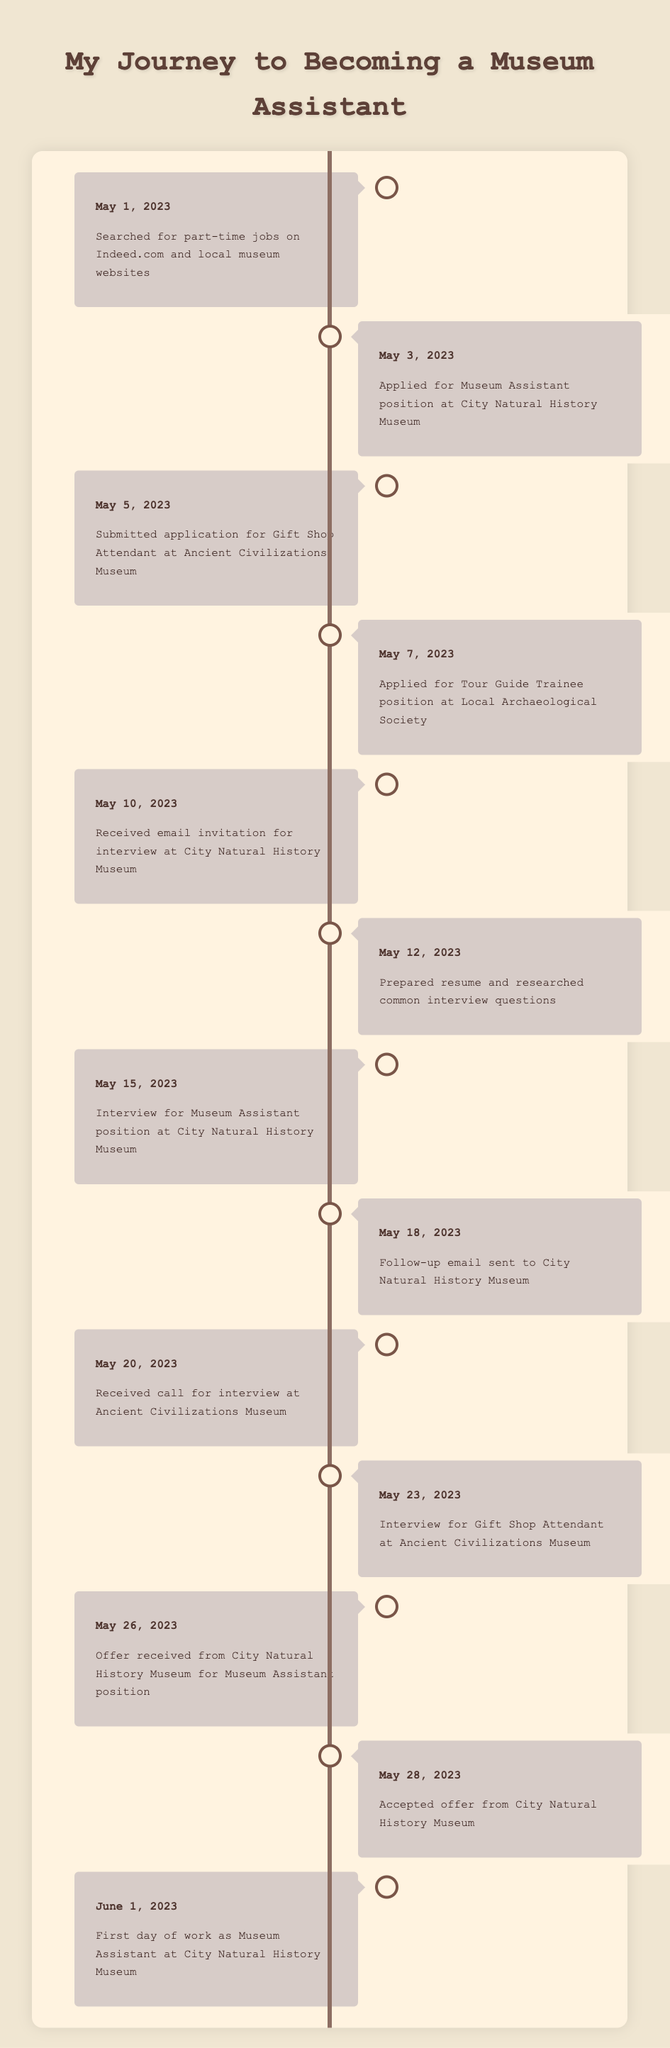What date did you apply for the Museum Assistant position? The application for the Museum Assistant position at the City Natural History Museum was submitted on May 3, 2023, as indicated in the timeline.
Answer: May 3, 2023 How many interviews did you have in total? There were two interviews listed in the timeline: the first for the Museum Assistant position on May 15, 2023, and the second for the Gift Shop Attendant on May 23, 2023. This totals to 2 interviews.
Answer: 2 What was the first event listed in the timeline? The first event in the timeline is "Searched for part-time jobs on Indeed.com and local museum websites," which occurred on May 1, 2023.
Answer: Searched for part-time jobs on Indeed.com and local museum websites Did you receive a job offer from the Ancient Civilizations Museum? There is no mention of receiving an offer from the Ancient Civilizations Museum in the timeline. Therefore, the answer is no.
Answer: No Which museum offered you a position, and when was it? The City Natural History Museum offered the Museum Assistant position on May 26, 2023. This can be determined from the corresponding entry in the timeline.
Answer: City Natural History Museum on May 26, 2023 How many days passed between the interview for the Museum Assistant and the offer received? The interview for the Museum Assistant took place on May 15, 2023, and the offer was received on May 26, 2023. The number of days between these two dates is 11 days. To confirm: May 15 to May 26 counts as 11 days.
Answer: 11 days What was the gap between accepting the offer and starting work? The offer from the City Natural History Museum was accepted on May 28, 2023, and the first day of work was June 1, 2023. This is a gap of 4 days. The calculations are straightforward: May 28 to June 1 is 4 days.
Answer: 4 days Which event occurred immediately before the follow-up email on May 18, 2023? The event immediately before the follow-up email on May 18, 2023, was the interview for the Museum Assistant position, which occurred on May 15, 2023, as noted in the timeline entries.
Answer: Interview for Museum Assistant position on May 15, 2023 What percentage of your applications resulted in an interview invitation? There were three applications submitted (Museum Assistant, Gift Shop Attendant, Tour Guide Trainee) and two resulted in interviews (Museum Assistant and Gift Shop Attendant). The percentage is calculated as (2/3) * 100, which gives approximately 66.67%.
Answer: 66.67% 